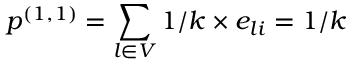<formula> <loc_0><loc_0><loc_500><loc_500>p ^ { ( 1 , 1 ) } = \sum _ { l \in V } { 1 / k \times e _ { l i } } = 1 / k</formula> 